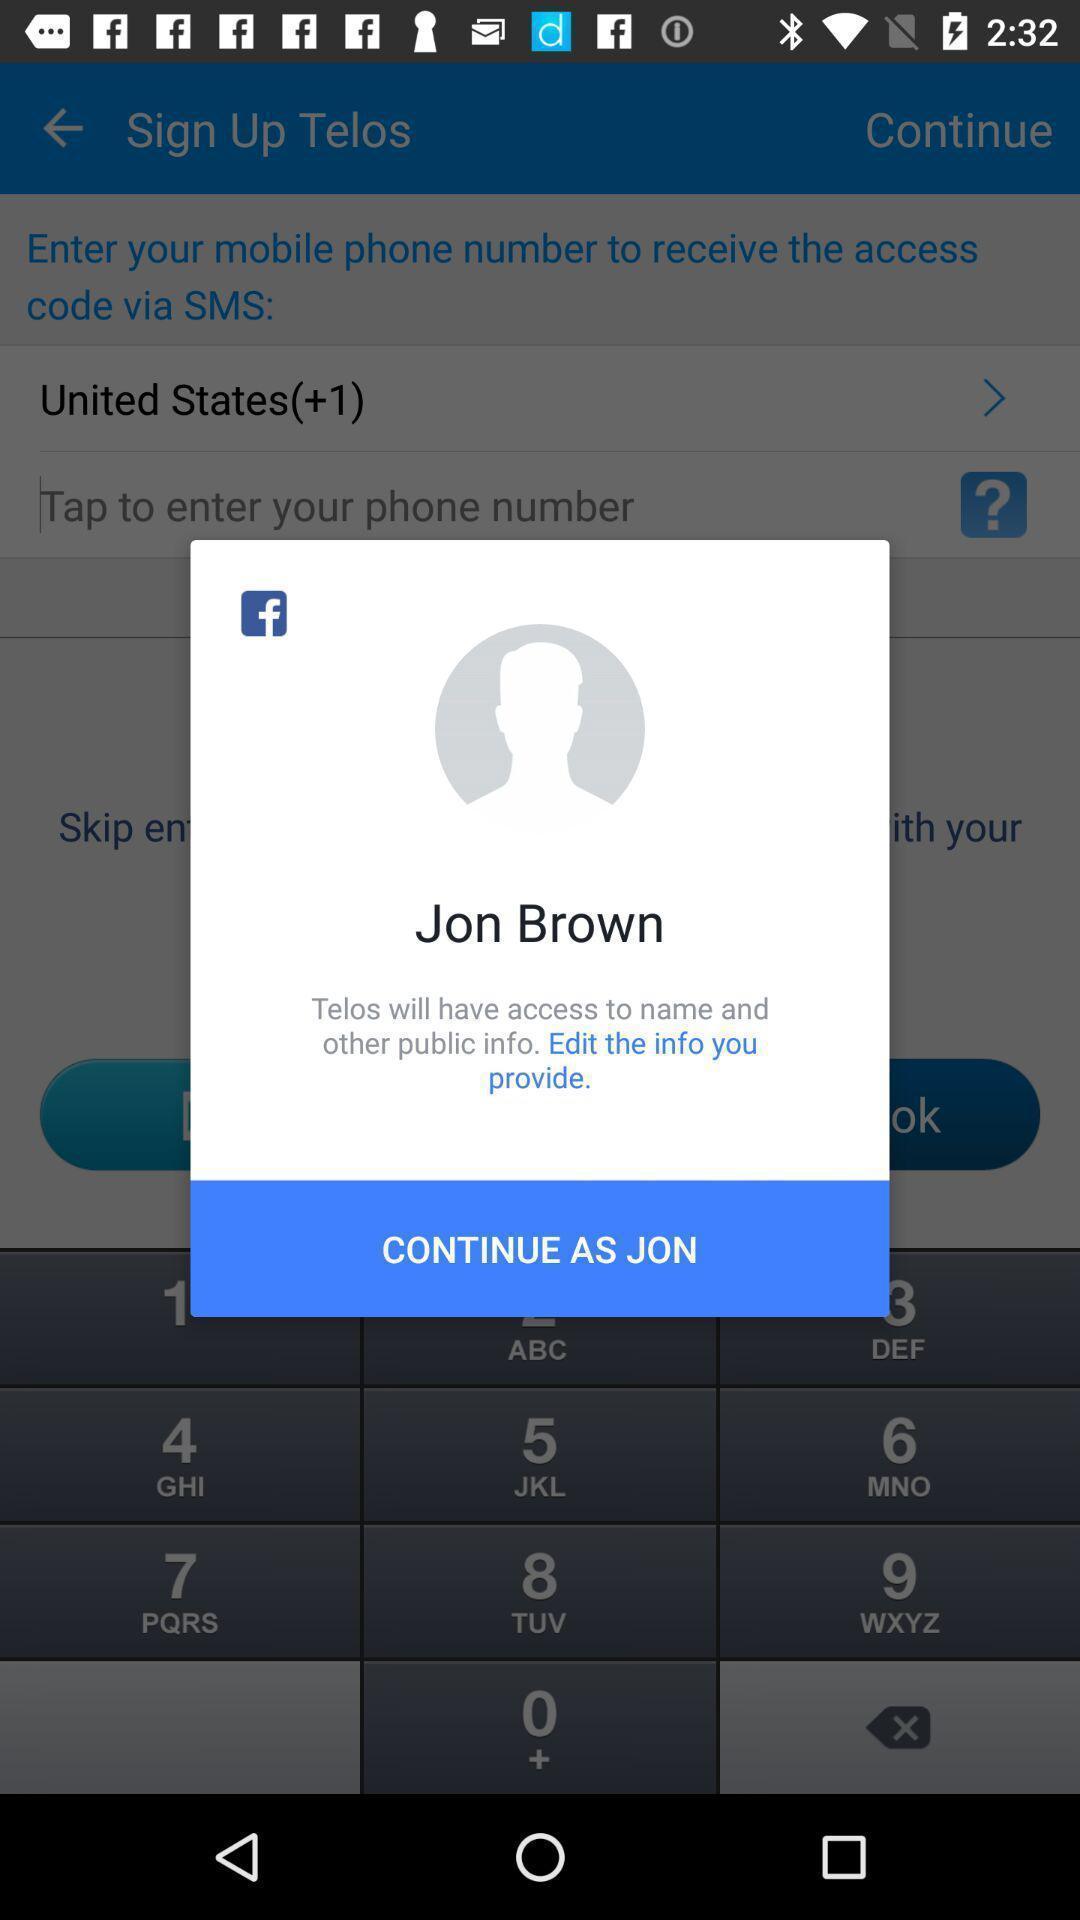What is the overall content of this screenshot? Pop up showing in social networking application. 